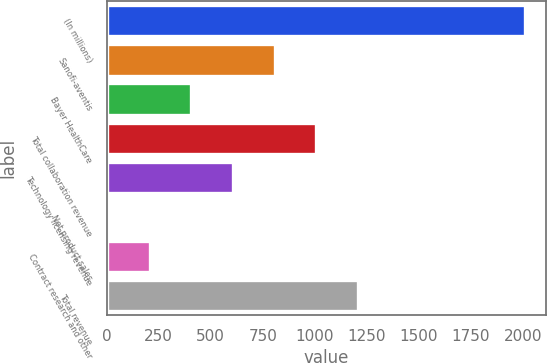Convert chart to OTSL. <chart><loc_0><loc_0><loc_500><loc_500><bar_chart><fcel>(In millions)<fcel>Sanofi-aventis<fcel>Bayer HealthCare<fcel>Total collaboration revenue<fcel>Technology licensing revenue<fcel>Net product sales<fcel>Contract research and other<fcel>Total revenue<nl><fcel>2008<fcel>806.98<fcel>406.64<fcel>1007.15<fcel>606.81<fcel>6.3<fcel>206.47<fcel>1207.32<nl></chart> 